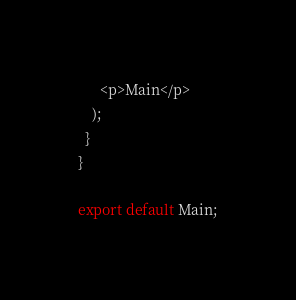<code> <loc_0><loc_0><loc_500><loc_500><_JavaScript_>      <p>Main</p>
    );
  }
}

export default Main;</code> 